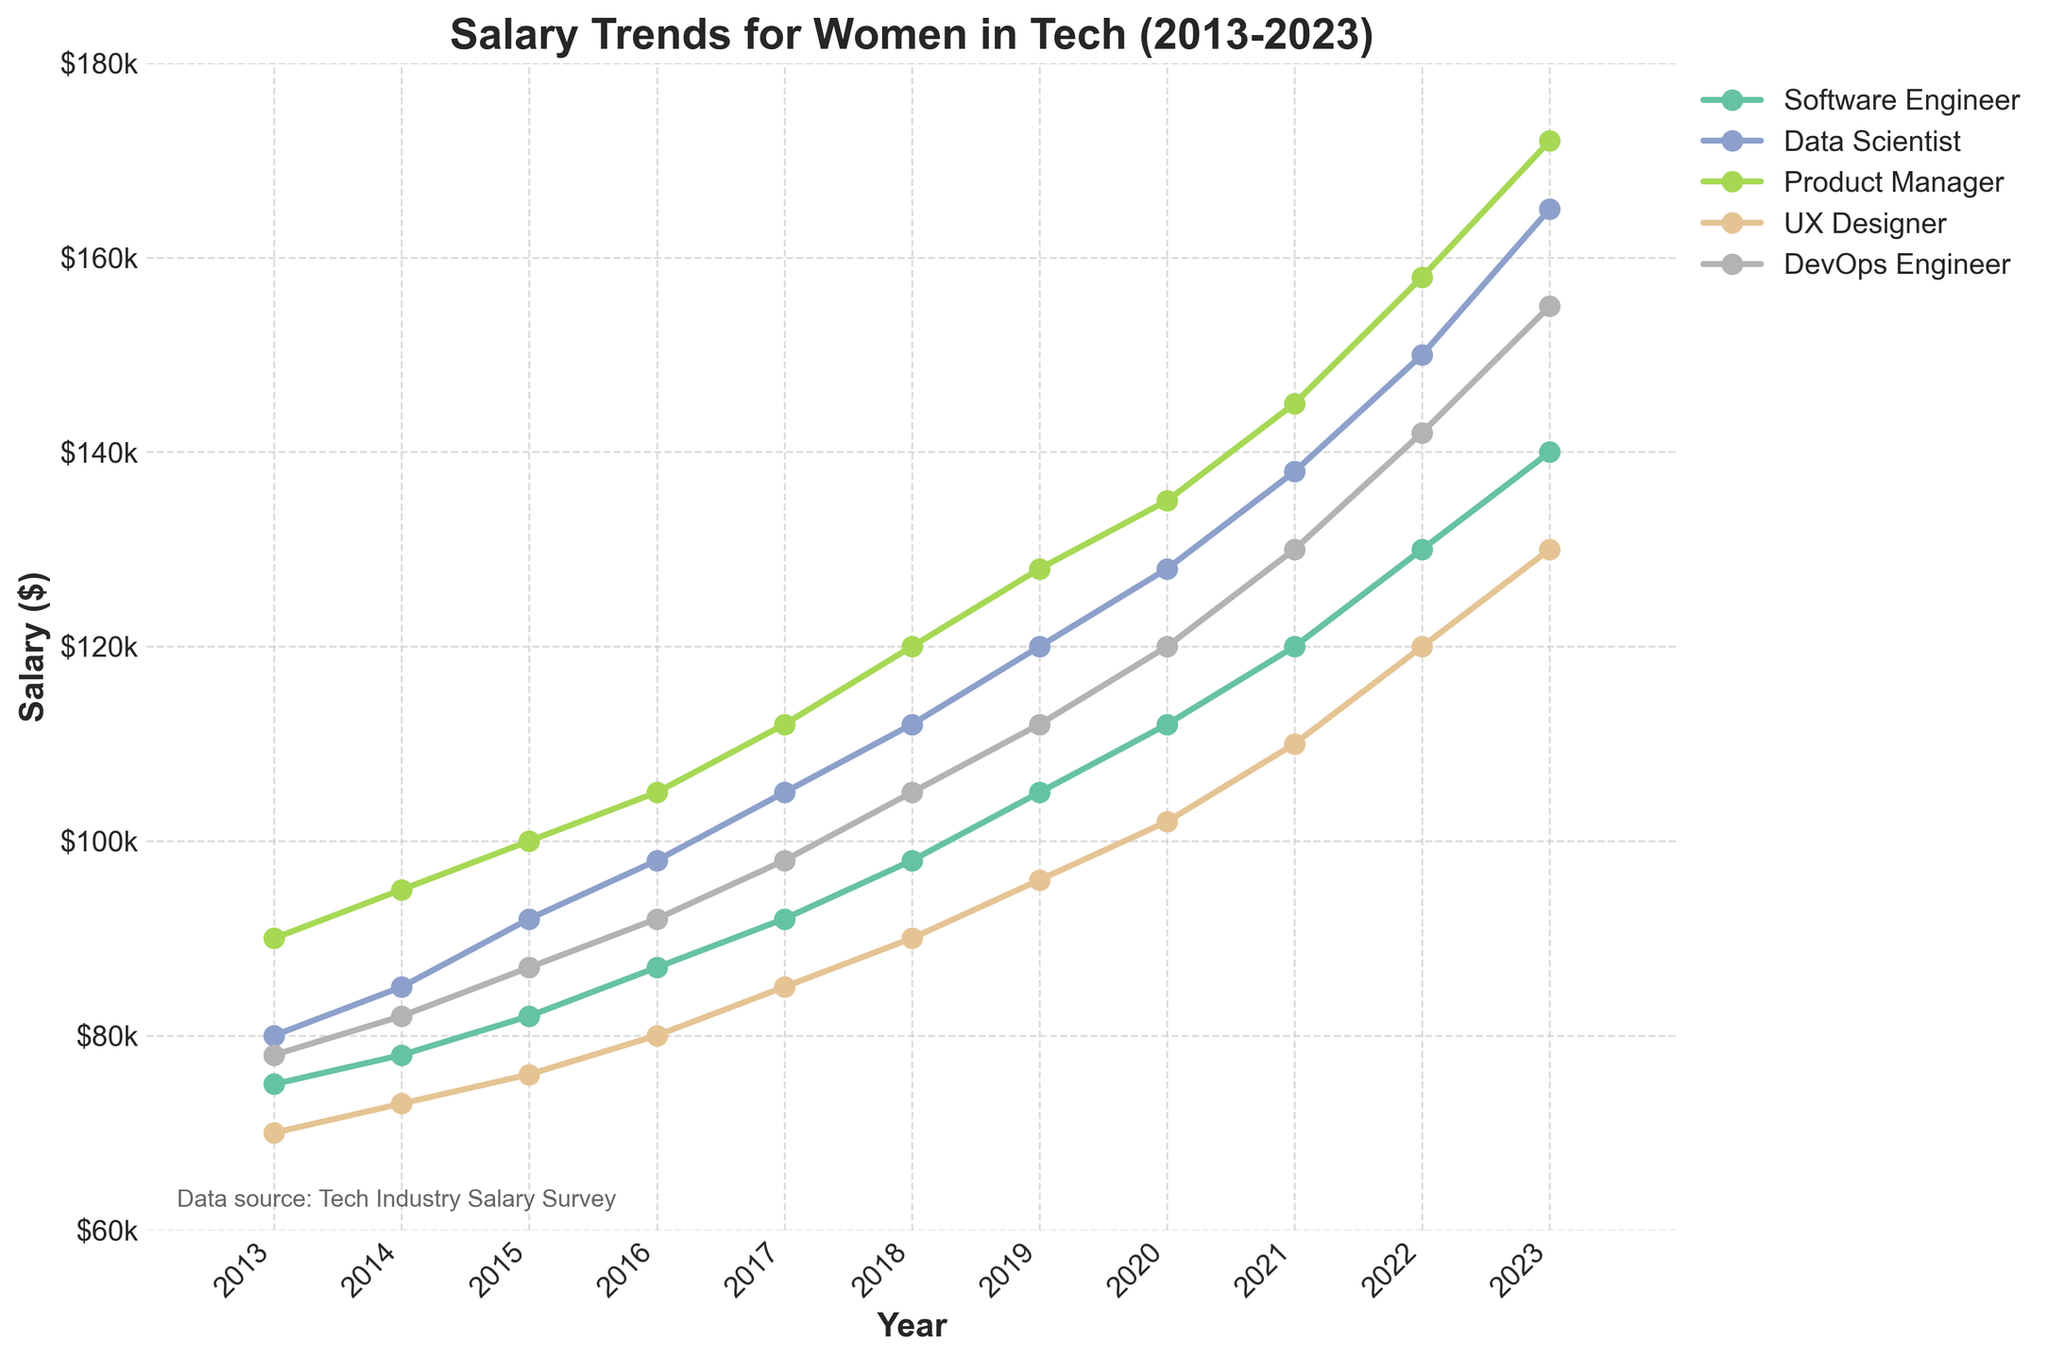Which role shows the highest salary growth from 2013 to 2023? To find the role with the highest salary growth, subtract the 2013 salary from the 2023 salary for each role. The growths are: Software Engineer = 140000 - 75000 = 65000, Data Scientist = 165000 - 80000 = 85000, Product Manager = 172000 - 90000 = 82000, UX Designer = 130000 - 70000 = 60000, DevOps Engineer = 155000 - 78000 = 77000. Therefore, the Data Scientist role has the highest growth.
Answer: Data Scientist Between 2017 and 2020, which role had the smallest salary increase? Find the salary increase for each role between 2017 and 2020: Software Engineer = 112000 - 92000 = 20000, Data Scientist = 128000 - 105000 = 23000, Product Manager = 135000 - 112000 = 23000, UX Designer = 102000 - 85000 = 17000, DevOps Engineer = 120000 - 98000 = 22000. The UX Designer role had the smallest increase.
Answer: UX Designer In which year did Product Managers see the largest year-over-year salary increase? Calculate the year-over-year salary increases for Product Managers: 2014 = 95000 - 90000 = 5000, 2015 = 100000 - 95000 = 5000, 2016 = 105000 - 100000 = 5000, 2017 = 112000 - 105000 = 7000, 2018 = 120000 - 112000 = 8000, 2019 = 128000 - 120000 = 8000, 2020 = 135000 - 128000 = 7000, 2021 = 145000 - 135000 = 10000, 2022 = 158000 - 145000 = 13000, 2023 = 172000 - 158000 = 14000. The largest increase happened between 2022 and 2023.
Answer: Between 2022 and 2023 What is the average salary of UX Designers in 2023? Find the salary value for UX Designers in 2023. Since there is only one value needed, no calculations are required beyond identifying the 2023 value for UX Designers from the chart, which is 130000.
Answer: 130000 What is the difference in salary between DevOps Engineers and Software Engineers in 2023? Locate the 2023 salary values for DevOps Engineers (155000) and Software Engineers (140000). Subtract the Software Engineer salary from the DevOps Engineer salary: 155000 - 140000 = 15000.
Answer: 15000 Which role had the highest salary in 2016? Find the salary values for each role in 2016: Software Engineer = 87000, Data Scientist = 98000, Product Manager = 105000, UX Designer = 80000, DevOps Engineer = 92000. The Product Manager role had the highest salary in 2016.
Answer: Product Manager By how much did the average salary for all roles increase from 2017 to 2020? First, find the average salary for all roles in 2017: (92000 + 105000 + 112000 + 85000 + 98000) / 5 = 98600. Then, calculate the average salary for 2020: (112000 + 128000 + 135000 + 102000 + 120000) / 5 = 119400. Finally, find the difference: 119400 - 98600 = 20800.
Answer: 20800 How did the salary trends of Data Scientists and DevOps Engineers compare between 2018 and 2023? Observe the trends for both roles. Data Scientist salaries increased from 112000 to 165000, with a total increase of 53000. DevOps Engineer salaries increased from 105000 to 155000, with a total increase of 50000. Both roles show steady increases, with Data Scientists experiencing a slightly higher overall increase.
Answer: Data Scientists experienced a higher overall increase In what year did Data Scientists surpass a salary of $100,000? Check the year when the Data Scientist salary first exceeded $100,000. In 2015, their salary was 92000, in 2016 it was 98000, and in 2017 it was 105000. Thus, they surpassed $100,000 in 2017.
Answer: 2017 Which role appeared to have the most stable (least volatile) salary growth trend over the decade? Evaluate the smoothness and consistency of each role's salary growth trend. UX Designer salaries consistently increased without large jumps or fluctuations, indicating the most stability.
Answer: UX Designer 